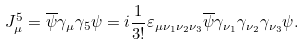<formula> <loc_0><loc_0><loc_500><loc_500>J _ { \mu } ^ { 5 } = \overline { \psi } \gamma _ { \mu } \gamma _ { 5 } \psi = i \frac { 1 } { 3 ! } \varepsilon _ { \mu \nu _ { 1 } \nu _ { 2 } \nu _ { 3 } } \overline { \psi } \gamma _ { \nu _ { 1 } } \gamma _ { \nu _ { 2 } } \gamma _ { \nu _ { 3 } } \psi .</formula> 